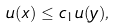<formula> <loc_0><loc_0><loc_500><loc_500>u ( x ) \leq c _ { 1 } u ( y ) ,</formula> 